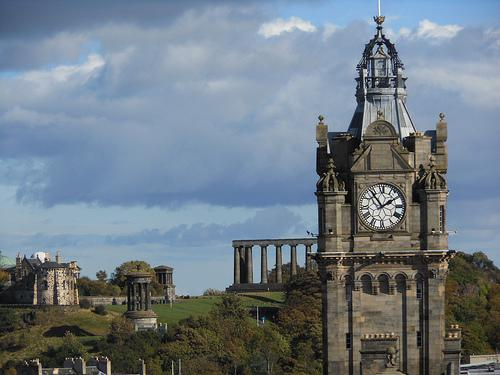Question: where was the photo taken?
Choices:
A. On a lake.
B. In a park.
C. On a hillside.
D. In a house.
Answer with the letter. Answer: C Question: what is in the photo?
Choices:
A. A child.
B. A clock.
C. A couch.
D. A television.
Answer with the letter. Answer: B Question: how is the weather?
Choices:
A. Rainy.
B. Cloudy.
C. Clear and sunny.
D. Hot and muggy.
Answer with the letter. Answer: C Question: what is the clock made of?
Choices:
A. Wood.
B. Stone.
C. Medal.
D. Tin.
Answer with the letter. Answer: B Question: how is the landscape?
Choices:
A. Rocky.
B. Raised lowland.
C. Green and maintained.
D. Sandy with ocean.
Answer with the letter. Answer: C 